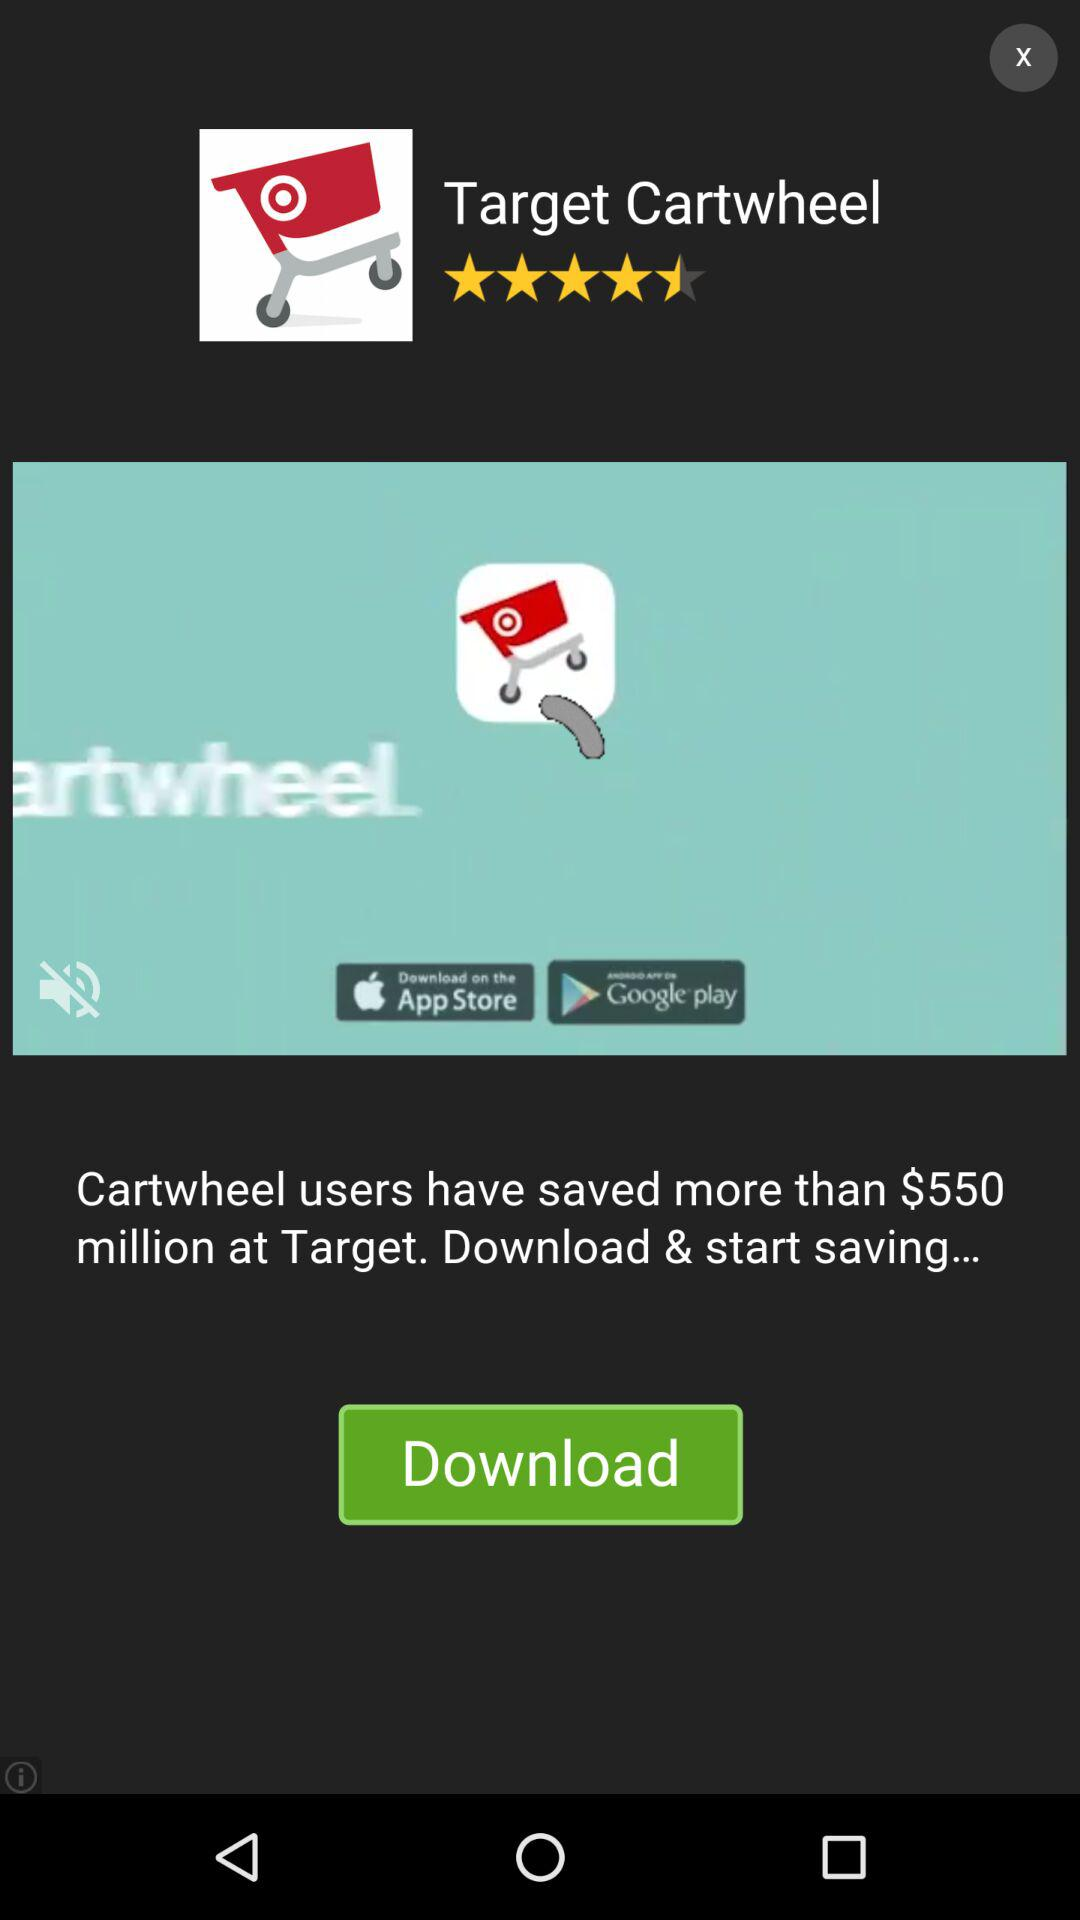What is the application name? The application name is "Target Cartwheel". 